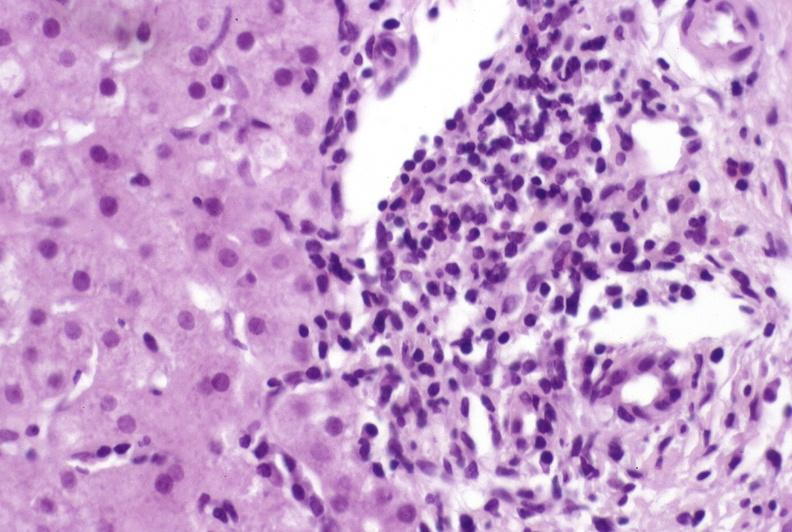what does this image show?
Answer the question using a single word or phrase. Primary biliary cirrhosis 